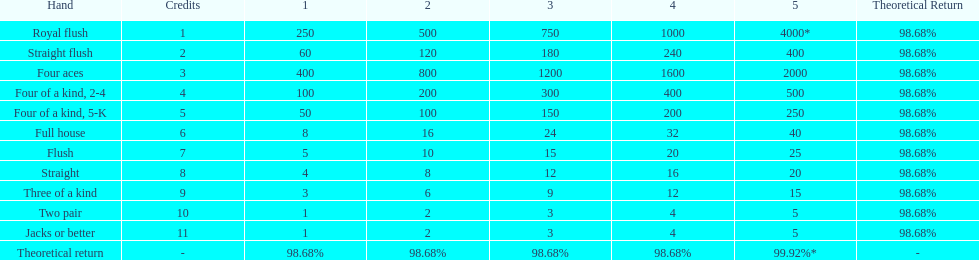Could you help me parse every detail presented in this table? {'header': ['Hand', 'Credits', '1', '2', '3', '4', '5', 'Theoretical Return'], 'rows': [['Royal flush', '1', '250', '500', '750', '1000', '4000*', '98.68%'], ['Straight flush', '2', '60', '120', '180', '240', '400', '98.68%'], ['Four aces', '3', '400', '800', '1200', '1600', '2000', '98.68%'], ['Four of a kind, 2-4', '4', '100', '200', '300', '400', '500', '98.68%'], ['Four of a kind, 5-K', '5', '50', '100', '150', '200', '250', '98.68%'], ['Full house', '6', '8', '16', '24', '32', '40', '98.68%'], ['Flush', '7', '5', '10', '15', '20', '25', '98.68%'], ['Straight', '8', '4', '8', '12', '16', '20', '98.68%'], ['Three of a kind', '9', '3', '6', '9', '12', '15', '98.68%'], ['Two pair', '10', '1', '2', '3', '4', '5', '98.68%'], ['Jacks or better', '11', '1', '2', '3', '4', '5', '98.68%'], ['Theoretical return', '-', '98.68%', '98.68%', '98.68%', '98.68%', '99.92%*', '-']]} After winning on four credits with a full house, what is your payout? 32. 